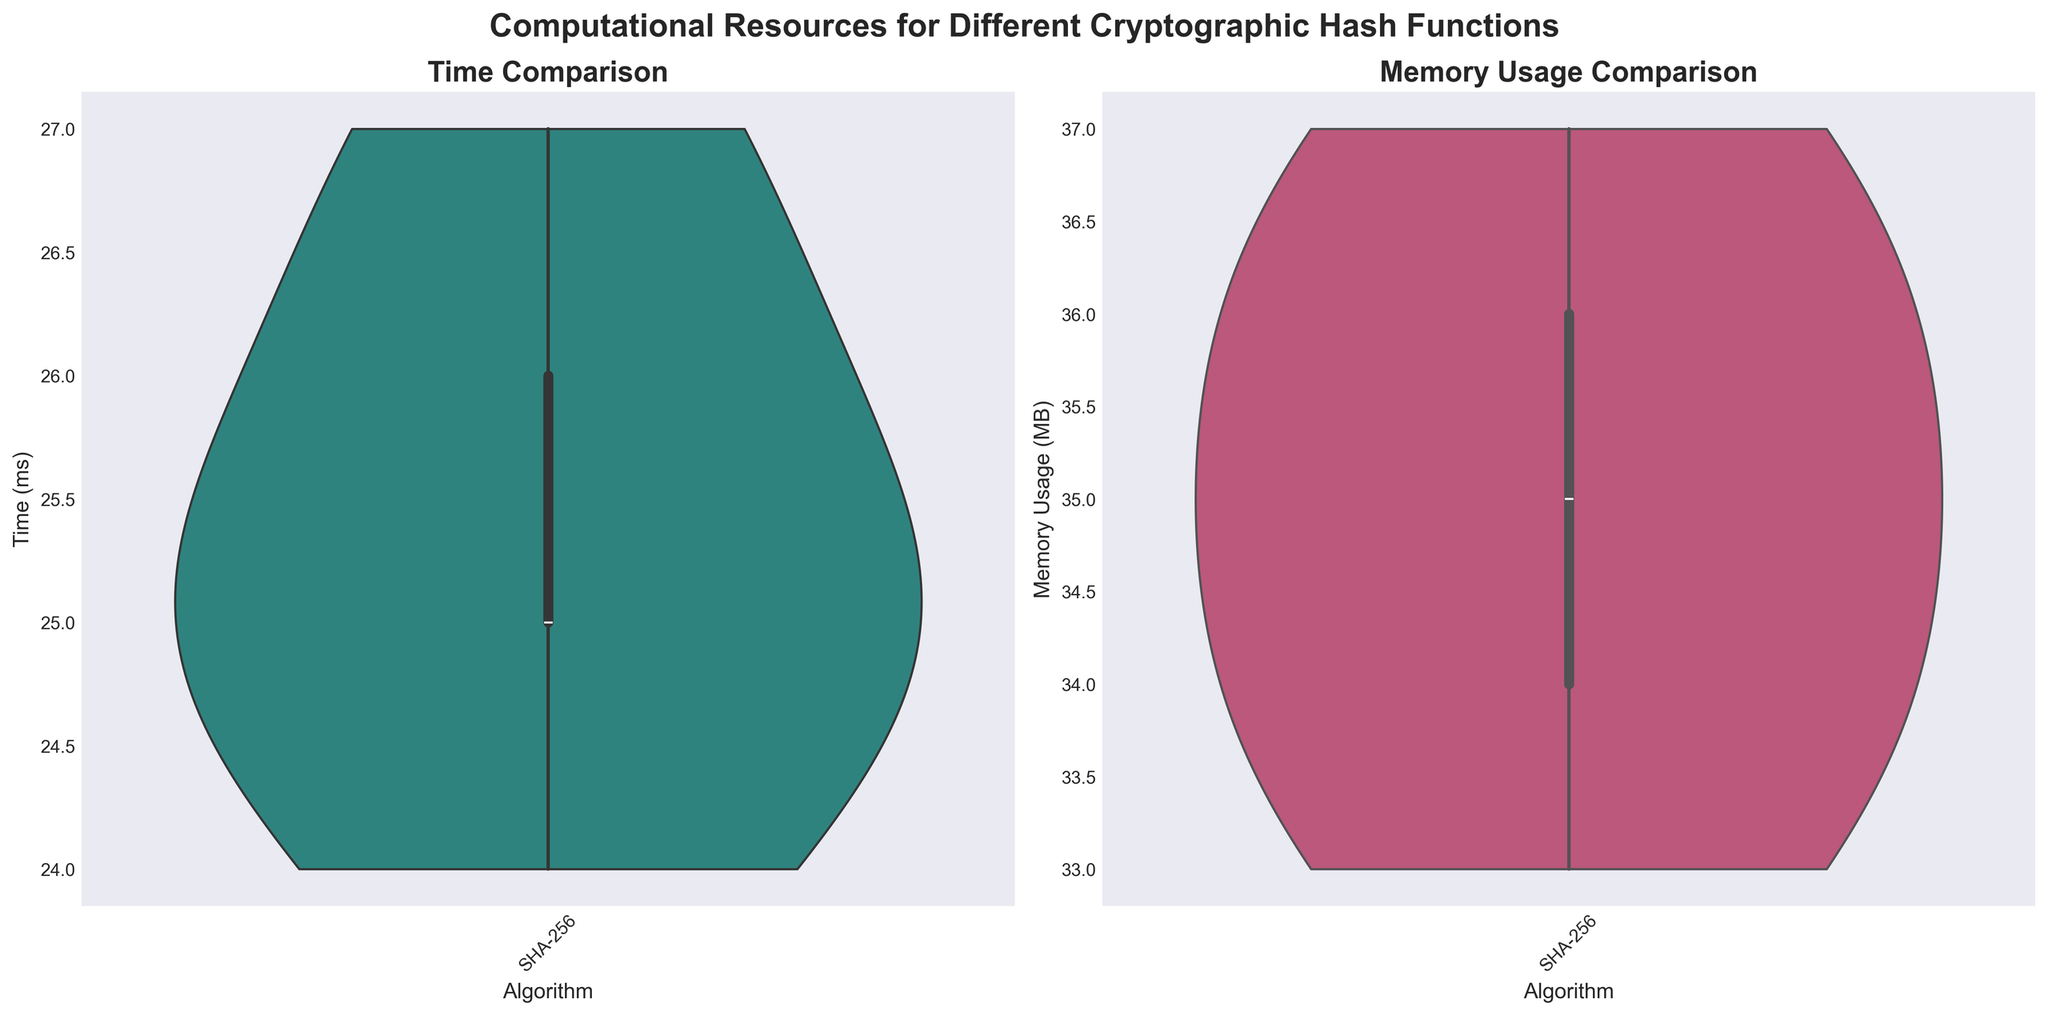What is the title of the figure? The title is written at the top center of the figure in bold and large font. It summarizes what the figure is about.
Answer: Computational Resources for Different Cryptographic Hash Functions What are the axes labels of the 'Time Comparison' plot? The axes labels are found next to the x-axis and y-axis of the 'Time Comparison' plot. The x-axis is labeled "Algorithm", and the y-axis is labeled "Time (ms)".
Answer: Algorithm, Time (ms) Which algorithm shows the highest median value for memory usage? The figure displays boxplots within the violin plot. The median value is represented by the line inside each box. Comparing the positions, SHA-3 has the highest median memory usage.
Answer: SHA-3 How does the median time for Blake2 compare to that of SHA-3? To compare, look at the median line (horizontal line inside the box) within the violin plot for both Blake2 and SHA-3 in the 'Time Comparison' plot. The median line for Blake2 is lower than that for SHA-3, indicating that Blake2 has a lower median time.
Answer: Blake2's median time is lower than SHA-3's median time What is the range of memory usage for Skein512? The range is determined by the spread of the data within the violin plot. The maximum and minimum points define the range. For Skein512, it spans from about 33 MB to 37 MB.
Answer: Approximately 33 MB to 37 MB Which algorithms have comparable memory usage distributions? Analyze the shapes and spreads of the violin plots in the 'Memory Usage Comparison' subplot. SHA-3 and Skein512 show comparable spreads and similar distributions, making them comparable.
Answer: SHA-3 and Skein512 Between SHA-256 and Blake2, which one has a lower variability in time taken? The box plot within the violin plot shows the spread of time values. A smaller spread of the data points within the box and whiskers indicates lower variability. Blake2 shows a more compact distribution compared to SHA-256, indicating lower variability.
Answer: Blake2 What can be said about the computational cost in terms of time for SHA-256 compared to Skein512? By examining the 'Time Comparison' plot, the central tendency (median) and the overall distribution shapes (width and height of the violins) suggest that SHA-256 generally takes less time compared to Skein512.
Answer: SHA-256 generally takes less time than Skein512 